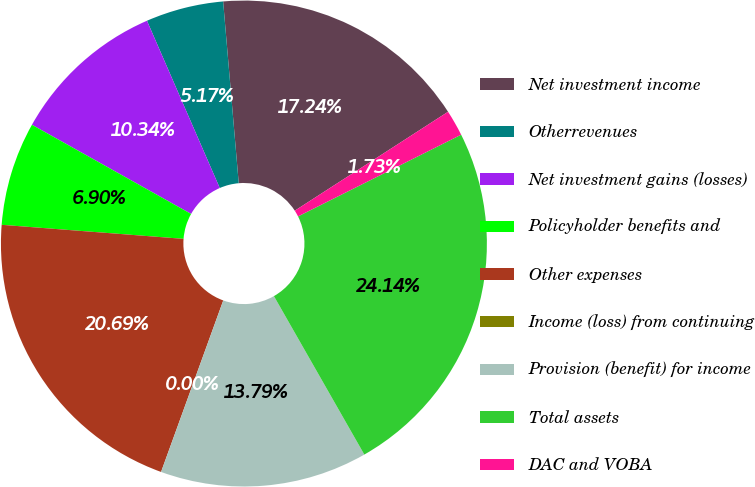Convert chart. <chart><loc_0><loc_0><loc_500><loc_500><pie_chart><fcel>Net investment income<fcel>Otherrevenues<fcel>Net investment gains (losses)<fcel>Policyholder benefits and<fcel>Other expenses<fcel>Income (loss) from continuing<fcel>Provision (benefit) for income<fcel>Total assets<fcel>DAC and VOBA<nl><fcel>17.24%<fcel>5.17%<fcel>10.34%<fcel>6.9%<fcel>20.69%<fcel>0.0%<fcel>13.79%<fcel>24.14%<fcel>1.73%<nl></chart> 